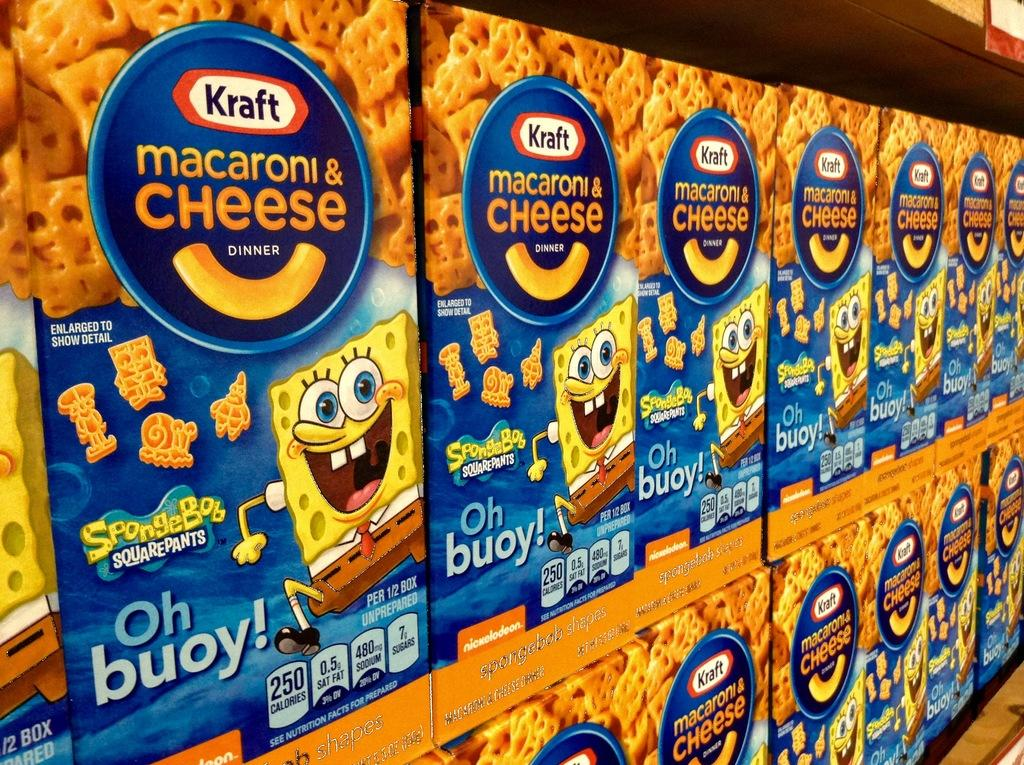What is the main subject of the image? The main subject of the image is many boxes. Where are the boxes located in the image? The boxes are kept on a shelf. What can be seen on at least one of the boxes? There is a picture of a cartoon on at least one box, and there is printed text on at least one box. What else can be seen on the boxes? There is a food item depicted on at least one box. How does the thumb contribute to the image? There is no thumb present in the image. What sense is being stimulated by the boxes in the image? The image is visual, so the sense being stimulated is sight. 